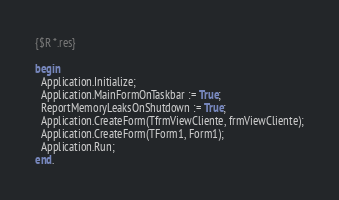Convert code to text. <code><loc_0><loc_0><loc_500><loc_500><_Pascal_>
{$R *.res}

begin
  Application.Initialize;
  Application.MainFormOnTaskbar := True;
  ReportMemoryLeaksOnShutdown := True;
  Application.CreateForm(TfrmViewCliente, frmViewCliente);
  Application.CreateForm(TForm1, Form1);
  Application.Run;
end.
</code> 